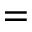<formula> <loc_0><loc_0><loc_500><loc_500>=</formula> 